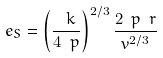Convert formula to latex. <formula><loc_0><loc_0><loc_500><loc_500>\ e _ { S } = \left ( \frac { \ k } { 4 \ p } \right ) ^ { 2 / 3 } \frac { 2 \ p \ r } { v ^ { 2 / 3 } }</formula> 